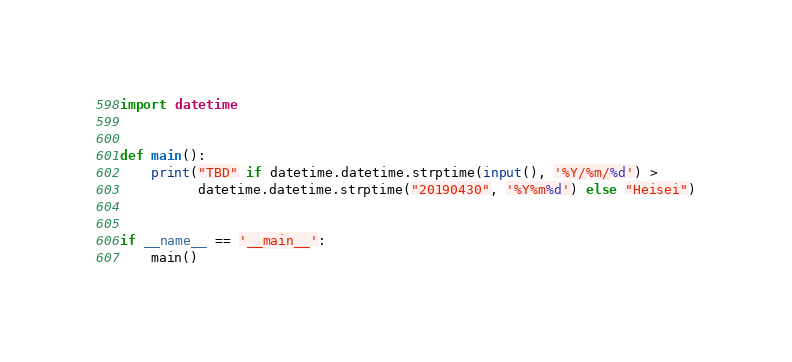<code> <loc_0><loc_0><loc_500><loc_500><_Python_>import datetime


def main():
    print("TBD" if datetime.datetime.strptime(input(), '%Y/%m/%d') >
          datetime.datetime.strptime("20190430", '%Y%m%d') else "Heisei")


if __name__ == '__main__':
    main()
</code> 